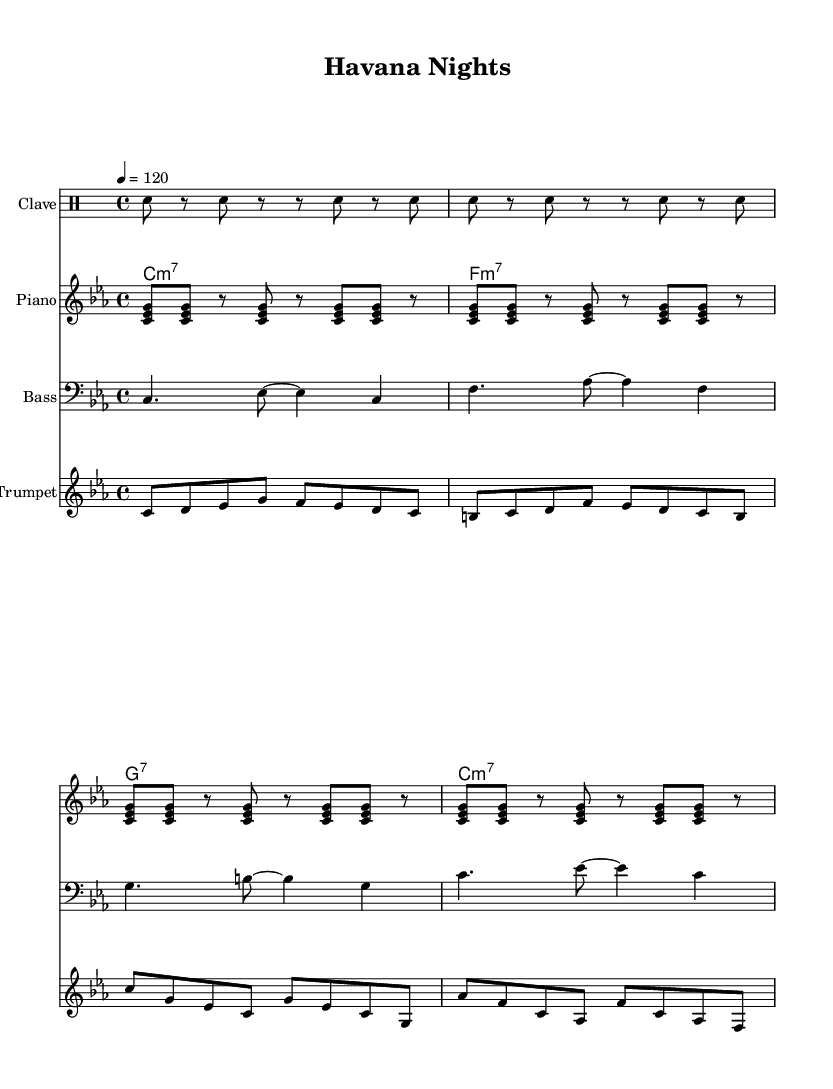What is the key signature of this music? The key signature is C minor, which has three flats: B♭, E♭, and A♭. You can determine the key signature by looking at the beginning of the staff where the key signature is indicated.
Answer: C minor What is the time signature of this music? The time signature is 4/4, which means there are four beats in each measure and a quarter note receives one beat. This is indicated at the beginning of the score right after the key signature.
Answer: 4/4 What is the tempo marking for this piece? The tempo marking is 120 beats per minute, shown explicitly in the tempo indication ("4 = 120"). This means the piece should be played at a moderate pace.
Answer: 120 What rhythmic pattern is played by the Clave? The Clave plays a repeating pattern that emphasizes specific rhythms typically found in Afro-Cuban music. It consists of an alternating pattern represented by two measures of rhythm; this can be identified in the drummode section where snare hits denote the clave.
Answer: Snare rhythm How many instruments are part of this score? The score features five distinct instrument parts: Clave, Synth Pad, Piano, Bass, and Trumpet. Each is explicitly indicated at the beginning of each staff in the score.
Answer: Five What is the role of the piano in this piece? The piano plays a montuno pattern, which is characterized by its repetitive and syncopated chords. This can be recognized by looking at the notes in the piano staff, showcasing a rhythmic pattern typical of Latin music.
Answer: Montuno pattern What type of chord progression is used in the Synth Pad? The Synth Pad employs a minor seventh chord progression moving from C minor to F minor to G seventh and back to C minor. This sequence gives a harmonic foundation typical in Latin jazz and can be concluded from the chord changes played in that section.
Answer: Minor seventh chords 